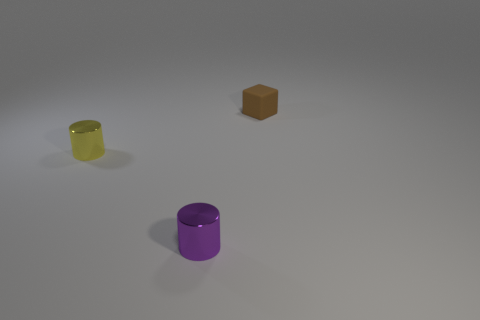Subtract all yellow cubes. Subtract all brown balls. How many cubes are left? 1 Add 2 large red rubber cubes. How many objects exist? 5 Subtract all cylinders. How many objects are left? 1 Add 2 tiny yellow shiny cylinders. How many tiny yellow shiny cylinders exist? 3 Subtract 0 gray cylinders. How many objects are left? 3 Subtract all small blue matte cubes. Subtract all yellow objects. How many objects are left? 2 Add 3 tiny blocks. How many tiny blocks are left? 4 